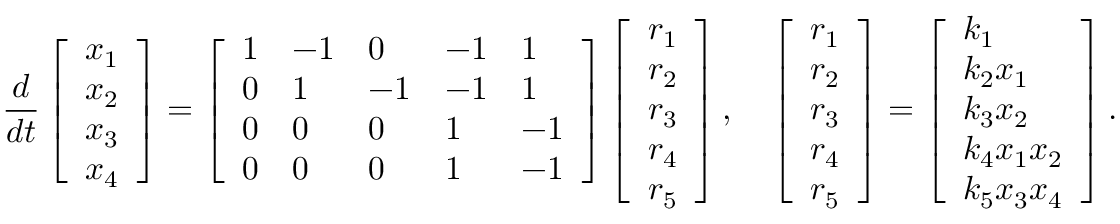Convert formula to latex. <formula><loc_0><loc_0><loc_500><loc_500>\frac { d } { d t } \left [ \begin{array} { l } { x _ { 1 } } \\ { x _ { 2 } } \\ { x _ { 3 } } \\ { x _ { 4 } } \end{array} \right ] = \left [ \begin{array} { l l l l l } { 1 } & { - 1 } & { 0 } & { - 1 } & { 1 } \\ { 0 } & { 1 } & { - 1 } & { - 1 } & { 1 } \\ { 0 } & { 0 } & { 0 } & { 1 } & { - 1 } \\ { 0 } & { 0 } & { 0 } & { 1 } & { - 1 } \end{array} \right ] \left [ \begin{array} { l } { r _ { 1 } } \\ { r _ { 2 } } \\ { r _ { 3 } } \\ { r _ { 4 } } \\ { r _ { 5 } } \end{array} \right ] , \quad \left [ \begin{array} { l } { r _ { 1 } } \\ { r _ { 2 } } \\ { r _ { 3 } } \\ { r _ { 4 } } \\ { r _ { 5 } } \end{array} \right ] = \left [ \begin{array} { l } { k _ { 1 } } \\ { k _ { 2 } x _ { 1 } } \\ { k _ { 3 } x _ { 2 } } \\ { k _ { 4 } x _ { 1 } x _ { 2 } } \\ { k _ { 5 } x _ { 3 } x _ { 4 } } \end{array} \right ] .</formula> 